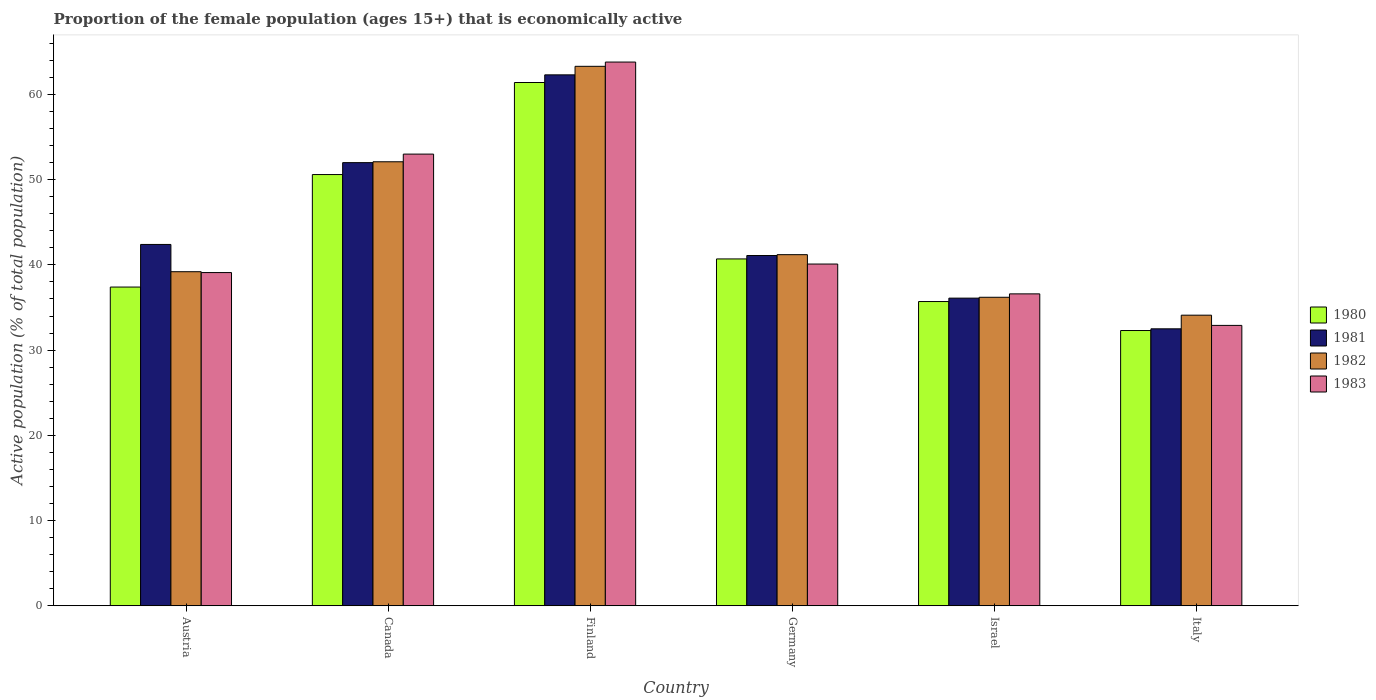How many groups of bars are there?
Your answer should be very brief. 6. Are the number of bars on each tick of the X-axis equal?
Provide a short and direct response. Yes. How many bars are there on the 1st tick from the left?
Give a very brief answer. 4. How many bars are there on the 4th tick from the right?
Keep it short and to the point. 4. What is the proportion of the female population that is economically active in 1980 in Canada?
Provide a short and direct response. 50.6. Across all countries, what is the maximum proportion of the female population that is economically active in 1980?
Make the answer very short. 61.4. Across all countries, what is the minimum proportion of the female population that is economically active in 1980?
Provide a short and direct response. 32.3. What is the total proportion of the female population that is economically active in 1980 in the graph?
Your answer should be compact. 258.1. What is the difference between the proportion of the female population that is economically active in 1981 in Canada and that in Finland?
Provide a short and direct response. -10.3. What is the difference between the proportion of the female population that is economically active in 1983 in Israel and the proportion of the female population that is economically active in 1980 in Canada?
Ensure brevity in your answer.  -14. What is the average proportion of the female population that is economically active in 1981 per country?
Ensure brevity in your answer.  44.4. What is the difference between the proportion of the female population that is economically active of/in 1983 and proportion of the female population that is economically active of/in 1982 in Canada?
Give a very brief answer. 0.9. In how many countries, is the proportion of the female population that is economically active in 1981 greater than 2 %?
Your response must be concise. 6. What is the ratio of the proportion of the female population that is economically active in 1982 in Austria to that in Israel?
Provide a succinct answer. 1.08. Is the difference between the proportion of the female population that is economically active in 1983 in Canada and Germany greater than the difference between the proportion of the female population that is economically active in 1982 in Canada and Germany?
Your answer should be compact. Yes. What is the difference between the highest and the second highest proportion of the female population that is economically active in 1983?
Your answer should be compact. -12.9. What is the difference between the highest and the lowest proportion of the female population that is economically active in 1980?
Offer a very short reply. 29.1. In how many countries, is the proportion of the female population that is economically active in 1983 greater than the average proportion of the female population that is economically active in 1983 taken over all countries?
Give a very brief answer. 2. How many bars are there?
Offer a terse response. 24. Are the values on the major ticks of Y-axis written in scientific E-notation?
Your answer should be compact. No. Does the graph contain grids?
Provide a succinct answer. No. What is the title of the graph?
Your answer should be compact. Proportion of the female population (ages 15+) that is economically active. Does "1976" appear as one of the legend labels in the graph?
Your response must be concise. No. What is the label or title of the X-axis?
Provide a short and direct response. Country. What is the label or title of the Y-axis?
Make the answer very short. Active population (% of total population). What is the Active population (% of total population) of 1980 in Austria?
Your response must be concise. 37.4. What is the Active population (% of total population) in 1981 in Austria?
Your answer should be very brief. 42.4. What is the Active population (% of total population) of 1982 in Austria?
Offer a very short reply. 39.2. What is the Active population (% of total population) in 1983 in Austria?
Your response must be concise. 39.1. What is the Active population (% of total population) of 1980 in Canada?
Offer a very short reply. 50.6. What is the Active population (% of total population) in 1982 in Canada?
Offer a terse response. 52.1. What is the Active population (% of total population) of 1980 in Finland?
Your response must be concise. 61.4. What is the Active population (% of total population) of 1981 in Finland?
Provide a succinct answer. 62.3. What is the Active population (% of total population) in 1982 in Finland?
Provide a short and direct response. 63.3. What is the Active population (% of total population) of 1983 in Finland?
Make the answer very short. 63.8. What is the Active population (% of total population) of 1980 in Germany?
Provide a short and direct response. 40.7. What is the Active population (% of total population) in 1981 in Germany?
Provide a short and direct response. 41.1. What is the Active population (% of total population) of 1982 in Germany?
Provide a succinct answer. 41.2. What is the Active population (% of total population) of 1983 in Germany?
Your answer should be very brief. 40.1. What is the Active population (% of total population) of 1980 in Israel?
Offer a terse response. 35.7. What is the Active population (% of total population) in 1981 in Israel?
Make the answer very short. 36.1. What is the Active population (% of total population) of 1982 in Israel?
Offer a terse response. 36.2. What is the Active population (% of total population) in 1983 in Israel?
Make the answer very short. 36.6. What is the Active population (% of total population) in 1980 in Italy?
Your answer should be very brief. 32.3. What is the Active population (% of total population) in 1981 in Italy?
Your answer should be very brief. 32.5. What is the Active population (% of total population) in 1982 in Italy?
Ensure brevity in your answer.  34.1. What is the Active population (% of total population) of 1983 in Italy?
Your answer should be very brief. 32.9. Across all countries, what is the maximum Active population (% of total population) of 1980?
Your answer should be compact. 61.4. Across all countries, what is the maximum Active population (% of total population) of 1981?
Provide a short and direct response. 62.3. Across all countries, what is the maximum Active population (% of total population) in 1982?
Your answer should be very brief. 63.3. Across all countries, what is the maximum Active population (% of total population) in 1983?
Ensure brevity in your answer.  63.8. Across all countries, what is the minimum Active population (% of total population) in 1980?
Offer a terse response. 32.3. Across all countries, what is the minimum Active population (% of total population) of 1981?
Your answer should be compact. 32.5. Across all countries, what is the minimum Active population (% of total population) of 1982?
Make the answer very short. 34.1. Across all countries, what is the minimum Active population (% of total population) in 1983?
Ensure brevity in your answer.  32.9. What is the total Active population (% of total population) of 1980 in the graph?
Keep it short and to the point. 258.1. What is the total Active population (% of total population) in 1981 in the graph?
Offer a very short reply. 266.4. What is the total Active population (% of total population) of 1982 in the graph?
Offer a terse response. 266.1. What is the total Active population (% of total population) in 1983 in the graph?
Make the answer very short. 265.5. What is the difference between the Active population (% of total population) of 1981 in Austria and that in Canada?
Make the answer very short. -9.6. What is the difference between the Active population (% of total population) of 1982 in Austria and that in Canada?
Your answer should be compact. -12.9. What is the difference between the Active population (% of total population) in 1980 in Austria and that in Finland?
Ensure brevity in your answer.  -24. What is the difference between the Active population (% of total population) of 1981 in Austria and that in Finland?
Offer a very short reply. -19.9. What is the difference between the Active population (% of total population) of 1982 in Austria and that in Finland?
Offer a terse response. -24.1. What is the difference between the Active population (% of total population) of 1983 in Austria and that in Finland?
Offer a terse response. -24.7. What is the difference between the Active population (% of total population) in 1980 in Austria and that in Germany?
Offer a very short reply. -3.3. What is the difference between the Active population (% of total population) in 1981 in Austria and that in Germany?
Make the answer very short. 1.3. What is the difference between the Active population (% of total population) of 1981 in Austria and that in Israel?
Provide a succinct answer. 6.3. What is the difference between the Active population (% of total population) of 1982 in Austria and that in Israel?
Offer a very short reply. 3. What is the difference between the Active population (% of total population) of 1982 in Austria and that in Italy?
Your response must be concise. 5.1. What is the difference between the Active population (% of total population) of 1983 in Austria and that in Italy?
Provide a succinct answer. 6.2. What is the difference between the Active population (% of total population) of 1980 in Canada and that in Finland?
Your response must be concise. -10.8. What is the difference between the Active population (% of total population) in 1982 in Canada and that in Finland?
Provide a short and direct response. -11.2. What is the difference between the Active population (% of total population) in 1983 in Canada and that in Finland?
Your response must be concise. -10.8. What is the difference between the Active population (% of total population) of 1982 in Canada and that in Germany?
Provide a succinct answer. 10.9. What is the difference between the Active population (% of total population) of 1983 in Canada and that in Germany?
Your answer should be compact. 12.9. What is the difference between the Active population (% of total population) in 1980 in Canada and that in Israel?
Make the answer very short. 14.9. What is the difference between the Active population (% of total population) of 1981 in Canada and that in Israel?
Your response must be concise. 15.9. What is the difference between the Active population (% of total population) in 1983 in Canada and that in Italy?
Provide a short and direct response. 20.1. What is the difference between the Active population (% of total population) of 1980 in Finland and that in Germany?
Provide a short and direct response. 20.7. What is the difference between the Active population (% of total population) of 1981 in Finland and that in Germany?
Make the answer very short. 21.2. What is the difference between the Active population (% of total population) in 1982 in Finland and that in Germany?
Provide a short and direct response. 22.1. What is the difference between the Active population (% of total population) in 1983 in Finland and that in Germany?
Your response must be concise. 23.7. What is the difference between the Active population (% of total population) in 1980 in Finland and that in Israel?
Provide a succinct answer. 25.7. What is the difference between the Active population (% of total population) in 1981 in Finland and that in Israel?
Make the answer very short. 26.2. What is the difference between the Active population (% of total population) of 1982 in Finland and that in Israel?
Your response must be concise. 27.1. What is the difference between the Active population (% of total population) of 1983 in Finland and that in Israel?
Provide a short and direct response. 27.2. What is the difference between the Active population (% of total population) of 1980 in Finland and that in Italy?
Offer a terse response. 29.1. What is the difference between the Active population (% of total population) in 1981 in Finland and that in Italy?
Your answer should be very brief. 29.8. What is the difference between the Active population (% of total population) in 1982 in Finland and that in Italy?
Offer a terse response. 29.2. What is the difference between the Active population (% of total population) in 1983 in Finland and that in Italy?
Provide a short and direct response. 30.9. What is the difference between the Active population (% of total population) in 1980 in Germany and that in Italy?
Your response must be concise. 8.4. What is the difference between the Active population (% of total population) of 1982 in Germany and that in Italy?
Ensure brevity in your answer.  7.1. What is the difference between the Active population (% of total population) in 1981 in Israel and that in Italy?
Offer a terse response. 3.6. What is the difference between the Active population (% of total population) in 1983 in Israel and that in Italy?
Provide a short and direct response. 3.7. What is the difference between the Active population (% of total population) in 1980 in Austria and the Active population (% of total population) in 1981 in Canada?
Your response must be concise. -14.6. What is the difference between the Active population (% of total population) in 1980 in Austria and the Active population (% of total population) in 1982 in Canada?
Give a very brief answer. -14.7. What is the difference between the Active population (% of total population) of 1980 in Austria and the Active population (% of total population) of 1983 in Canada?
Your answer should be compact. -15.6. What is the difference between the Active population (% of total population) of 1981 in Austria and the Active population (% of total population) of 1983 in Canada?
Make the answer very short. -10.6. What is the difference between the Active population (% of total population) in 1982 in Austria and the Active population (% of total population) in 1983 in Canada?
Give a very brief answer. -13.8. What is the difference between the Active population (% of total population) of 1980 in Austria and the Active population (% of total population) of 1981 in Finland?
Offer a terse response. -24.9. What is the difference between the Active population (% of total population) of 1980 in Austria and the Active population (% of total population) of 1982 in Finland?
Your response must be concise. -25.9. What is the difference between the Active population (% of total population) in 1980 in Austria and the Active population (% of total population) in 1983 in Finland?
Your response must be concise. -26.4. What is the difference between the Active population (% of total population) in 1981 in Austria and the Active population (% of total population) in 1982 in Finland?
Make the answer very short. -20.9. What is the difference between the Active population (% of total population) in 1981 in Austria and the Active population (% of total population) in 1983 in Finland?
Your answer should be very brief. -21.4. What is the difference between the Active population (% of total population) of 1982 in Austria and the Active population (% of total population) of 1983 in Finland?
Offer a terse response. -24.6. What is the difference between the Active population (% of total population) in 1981 in Austria and the Active population (% of total population) in 1983 in Germany?
Offer a very short reply. 2.3. What is the difference between the Active population (% of total population) in 1982 in Austria and the Active population (% of total population) in 1983 in Germany?
Provide a short and direct response. -0.9. What is the difference between the Active population (% of total population) in 1980 in Austria and the Active population (% of total population) in 1983 in Israel?
Offer a terse response. 0.8. What is the difference between the Active population (% of total population) of 1981 in Austria and the Active population (% of total population) of 1982 in Israel?
Your response must be concise. 6.2. What is the difference between the Active population (% of total population) of 1981 in Austria and the Active population (% of total population) of 1983 in Israel?
Provide a short and direct response. 5.8. What is the difference between the Active population (% of total population) in 1982 in Austria and the Active population (% of total population) in 1983 in Israel?
Make the answer very short. 2.6. What is the difference between the Active population (% of total population) of 1980 in Austria and the Active population (% of total population) of 1982 in Italy?
Offer a very short reply. 3.3. What is the difference between the Active population (% of total population) of 1981 in Austria and the Active population (% of total population) of 1983 in Italy?
Provide a short and direct response. 9.5. What is the difference between the Active population (% of total population) of 1982 in Austria and the Active population (% of total population) of 1983 in Italy?
Offer a terse response. 6.3. What is the difference between the Active population (% of total population) in 1980 in Canada and the Active population (% of total population) in 1981 in Finland?
Offer a very short reply. -11.7. What is the difference between the Active population (% of total population) in 1980 in Canada and the Active population (% of total population) in 1982 in Finland?
Provide a short and direct response. -12.7. What is the difference between the Active population (% of total population) of 1981 in Canada and the Active population (% of total population) of 1982 in Finland?
Offer a very short reply. -11.3. What is the difference between the Active population (% of total population) in 1982 in Canada and the Active population (% of total population) in 1983 in Finland?
Give a very brief answer. -11.7. What is the difference between the Active population (% of total population) of 1980 in Canada and the Active population (% of total population) of 1982 in Germany?
Your response must be concise. 9.4. What is the difference between the Active population (% of total population) in 1981 in Canada and the Active population (% of total population) in 1982 in Germany?
Keep it short and to the point. 10.8. What is the difference between the Active population (% of total population) in 1981 in Canada and the Active population (% of total population) in 1983 in Germany?
Make the answer very short. 11.9. What is the difference between the Active population (% of total population) of 1982 in Canada and the Active population (% of total population) of 1983 in Germany?
Give a very brief answer. 12. What is the difference between the Active population (% of total population) in 1980 in Canada and the Active population (% of total population) in 1982 in Israel?
Offer a terse response. 14.4. What is the difference between the Active population (% of total population) in 1980 in Canada and the Active population (% of total population) in 1981 in Italy?
Offer a very short reply. 18.1. What is the difference between the Active population (% of total population) of 1980 in Canada and the Active population (% of total population) of 1982 in Italy?
Offer a very short reply. 16.5. What is the difference between the Active population (% of total population) in 1980 in Canada and the Active population (% of total population) in 1983 in Italy?
Ensure brevity in your answer.  17.7. What is the difference between the Active population (% of total population) in 1980 in Finland and the Active population (% of total population) in 1981 in Germany?
Offer a very short reply. 20.3. What is the difference between the Active population (% of total population) in 1980 in Finland and the Active population (% of total population) in 1982 in Germany?
Your response must be concise. 20.2. What is the difference between the Active population (% of total population) of 1980 in Finland and the Active population (% of total population) of 1983 in Germany?
Offer a very short reply. 21.3. What is the difference between the Active population (% of total population) of 1981 in Finland and the Active population (% of total population) of 1982 in Germany?
Ensure brevity in your answer.  21.1. What is the difference between the Active population (% of total population) of 1982 in Finland and the Active population (% of total population) of 1983 in Germany?
Keep it short and to the point. 23.2. What is the difference between the Active population (% of total population) of 1980 in Finland and the Active population (% of total population) of 1981 in Israel?
Offer a very short reply. 25.3. What is the difference between the Active population (% of total population) in 1980 in Finland and the Active population (% of total population) in 1982 in Israel?
Make the answer very short. 25.2. What is the difference between the Active population (% of total population) of 1980 in Finland and the Active population (% of total population) of 1983 in Israel?
Provide a succinct answer. 24.8. What is the difference between the Active population (% of total population) of 1981 in Finland and the Active population (% of total population) of 1982 in Israel?
Keep it short and to the point. 26.1. What is the difference between the Active population (% of total population) of 1981 in Finland and the Active population (% of total population) of 1983 in Israel?
Your answer should be compact. 25.7. What is the difference between the Active population (% of total population) in 1982 in Finland and the Active population (% of total population) in 1983 in Israel?
Offer a terse response. 26.7. What is the difference between the Active population (% of total population) in 1980 in Finland and the Active population (% of total population) in 1981 in Italy?
Provide a succinct answer. 28.9. What is the difference between the Active population (% of total population) of 1980 in Finland and the Active population (% of total population) of 1982 in Italy?
Your response must be concise. 27.3. What is the difference between the Active population (% of total population) in 1980 in Finland and the Active population (% of total population) in 1983 in Italy?
Keep it short and to the point. 28.5. What is the difference between the Active population (% of total population) in 1981 in Finland and the Active population (% of total population) in 1982 in Italy?
Ensure brevity in your answer.  28.2. What is the difference between the Active population (% of total population) of 1981 in Finland and the Active population (% of total population) of 1983 in Italy?
Offer a very short reply. 29.4. What is the difference between the Active population (% of total population) of 1982 in Finland and the Active population (% of total population) of 1983 in Italy?
Offer a terse response. 30.4. What is the difference between the Active population (% of total population) in 1980 in Germany and the Active population (% of total population) in 1981 in Israel?
Your response must be concise. 4.6. What is the difference between the Active population (% of total population) in 1981 in Germany and the Active population (% of total population) in 1982 in Israel?
Offer a very short reply. 4.9. What is the difference between the Active population (% of total population) of 1980 in Germany and the Active population (% of total population) of 1981 in Italy?
Keep it short and to the point. 8.2. What is the difference between the Active population (% of total population) of 1980 in Germany and the Active population (% of total population) of 1982 in Italy?
Offer a very short reply. 6.6. What is the difference between the Active population (% of total population) of 1981 in Germany and the Active population (% of total population) of 1982 in Italy?
Offer a terse response. 7. What is the difference between the Active population (% of total population) in 1981 in Germany and the Active population (% of total population) in 1983 in Italy?
Your answer should be very brief. 8.2. What is the difference between the Active population (% of total population) of 1980 in Israel and the Active population (% of total population) of 1982 in Italy?
Your answer should be compact. 1.6. What is the difference between the Active population (% of total population) of 1981 in Israel and the Active population (% of total population) of 1983 in Italy?
Offer a terse response. 3.2. What is the difference between the Active population (% of total population) of 1982 in Israel and the Active population (% of total population) of 1983 in Italy?
Keep it short and to the point. 3.3. What is the average Active population (% of total population) of 1980 per country?
Keep it short and to the point. 43.02. What is the average Active population (% of total population) of 1981 per country?
Your answer should be compact. 44.4. What is the average Active population (% of total population) in 1982 per country?
Provide a short and direct response. 44.35. What is the average Active population (% of total population) in 1983 per country?
Ensure brevity in your answer.  44.25. What is the difference between the Active population (% of total population) of 1981 and Active population (% of total population) of 1982 in Austria?
Ensure brevity in your answer.  3.2. What is the difference between the Active population (% of total population) of 1981 and Active population (% of total population) of 1983 in Austria?
Ensure brevity in your answer.  3.3. What is the difference between the Active population (% of total population) of 1982 and Active population (% of total population) of 1983 in Austria?
Make the answer very short. 0.1. What is the difference between the Active population (% of total population) of 1981 and Active population (% of total population) of 1983 in Canada?
Give a very brief answer. -1. What is the difference between the Active population (% of total population) in 1980 and Active population (% of total population) in 1983 in Finland?
Provide a short and direct response. -2.4. What is the difference between the Active population (% of total population) in 1981 and Active population (% of total population) in 1982 in Finland?
Offer a very short reply. -1. What is the difference between the Active population (% of total population) of 1982 and Active population (% of total population) of 1983 in Finland?
Offer a terse response. -0.5. What is the difference between the Active population (% of total population) of 1980 and Active population (% of total population) of 1981 in Germany?
Offer a terse response. -0.4. What is the difference between the Active population (% of total population) of 1980 and Active population (% of total population) of 1983 in Germany?
Your response must be concise. 0.6. What is the difference between the Active population (% of total population) of 1981 and Active population (% of total population) of 1982 in Germany?
Offer a very short reply. -0.1. What is the difference between the Active population (% of total population) in 1981 and Active population (% of total population) in 1983 in Germany?
Give a very brief answer. 1. What is the difference between the Active population (% of total population) in 1980 and Active population (% of total population) in 1981 in Israel?
Make the answer very short. -0.4. What is the difference between the Active population (% of total population) in 1981 and Active population (% of total population) in 1982 in Israel?
Your answer should be very brief. -0.1. What is the difference between the Active population (% of total population) of 1981 and Active population (% of total population) of 1983 in Israel?
Provide a succinct answer. -0.5. What is the difference between the Active population (% of total population) in 1982 and Active population (% of total population) in 1983 in Israel?
Your answer should be compact. -0.4. What is the difference between the Active population (% of total population) in 1980 and Active population (% of total population) in 1983 in Italy?
Make the answer very short. -0.6. What is the difference between the Active population (% of total population) of 1981 and Active population (% of total population) of 1982 in Italy?
Offer a terse response. -1.6. What is the difference between the Active population (% of total population) in 1981 and Active population (% of total population) in 1983 in Italy?
Your response must be concise. -0.4. What is the difference between the Active population (% of total population) of 1982 and Active population (% of total population) of 1983 in Italy?
Offer a terse response. 1.2. What is the ratio of the Active population (% of total population) in 1980 in Austria to that in Canada?
Offer a terse response. 0.74. What is the ratio of the Active population (% of total population) of 1981 in Austria to that in Canada?
Provide a succinct answer. 0.82. What is the ratio of the Active population (% of total population) of 1982 in Austria to that in Canada?
Make the answer very short. 0.75. What is the ratio of the Active population (% of total population) of 1983 in Austria to that in Canada?
Offer a very short reply. 0.74. What is the ratio of the Active population (% of total population) of 1980 in Austria to that in Finland?
Provide a succinct answer. 0.61. What is the ratio of the Active population (% of total population) of 1981 in Austria to that in Finland?
Provide a short and direct response. 0.68. What is the ratio of the Active population (% of total population) in 1982 in Austria to that in Finland?
Your answer should be very brief. 0.62. What is the ratio of the Active population (% of total population) in 1983 in Austria to that in Finland?
Offer a terse response. 0.61. What is the ratio of the Active population (% of total population) of 1980 in Austria to that in Germany?
Ensure brevity in your answer.  0.92. What is the ratio of the Active population (% of total population) of 1981 in Austria to that in Germany?
Give a very brief answer. 1.03. What is the ratio of the Active population (% of total population) in 1982 in Austria to that in Germany?
Provide a short and direct response. 0.95. What is the ratio of the Active population (% of total population) in 1983 in Austria to that in Germany?
Provide a succinct answer. 0.98. What is the ratio of the Active population (% of total population) in 1980 in Austria to that in Israel?
Ensure brevity in your answer.  1.05. What is the ratio of the Active population (% of total population) in 1981 in Austria to that in Israel?
Provide a succinct answer. 1.17. What is the ratio of the Active population (% of total population) of 1982 in Austria to that in Israel?
Make the answer very short. 1.08. What is the ratio of the Active population (% of total population) in 1983 in Austria to that in Israel?
Your answer should be very brief. 1.07. What is the ratio of the Active population (% of total population) of 1980 in Austria to that in Italy?
Provide a short and direct response. 1.16. What is the ratio of the Active population (% of total population) of 1981 in Austria to that in Italy?
Make the answer very short. 1.3. What is the ratio of the Active population (% of total population) in 1982 in Austria to that in Italy?
Provide a succinct answer. 1.15. What is the ratio of the Active population (% of total population) of 1983 in Austria to that in Italy?
Provide a short and direct response. 1.19. What is the ratio of the Active population (% of total population) of 1980 in Canada to that in Finland?
Make the answer very short. 0.82. What is the ratio of the Active population (% of total population) in 1981 in Canada to that in Finland?
Your answer should be very brief. 0.83. What is the ratio of the Active population (% of total population) of 1982 in Canada to that in Finland?
Offer a terse response. 0.82. What is the ratio of the Active population (% of total population) of 1983 in Canada to that in Finland?
Your answer should be very brief. 0.83. What is the ratio of the Active population (% of total population) of 1980 in Canada to that in Germany?
Keep it short and to the point. 1.24. What is the ratio of the Active population (% of total population) in 1981 in Canada to that in Germany?
Keep it short and to the point. 1.27. What is the ratio of the Active population (% of total population) in 1982 in Canada to that in Germany?
Your answer should be compact. 1.26. What is the ratio of the Active population (% of total population) of 1983 in Canada to that in Germany?
Keep it short and to the point. 1.32. What is the ratio of the Active population (% of total population) in 1980 in Canada to that in Israel?
Provide a succinct answer. 1.42. What is the ratio of the Active population (% of total population) in 1981 in Canada to that in Israel?
Provide a succinct answer. 1.44. What is the ratio of the Active population (% of total population) in 1982 in Canada to that in Israel?
Offer a terse response. 1.44. What is the ratio of the Active population (% of total population) of 1983 in Canada to that in Israel?
Ensure brevity in your answer.  1.45. What is the ratio of the Active population (% of total population) in 1980 in Canada to that in Italy?
Offer a very short reply. 1.57. What is the ratio of the Active population (% of total population) in 1982 in Canada to that in Italy?
Offer a very short reply. 1.53. What is the ratio of the Active population (% of total population) of 1983 in Canada to that in Italy?
Make the answer very short. 1.61. What is the ratio of the Active population (% of total population) of 1980 in Finland to that in Germany?
Your response must be concise. 1.51. What is the ratio of the Active population (% of total population) of 1981 in Finland to that in Germany?
Offer a terse response. 1.52. What is the ratio of the Active population (% of total population) of 1982 in Finland to that in Germany?
Your response must be concise. 1.54. What is the ratio of the Active population (% of total population) of 1983 in Finland to that in Germany?
Your answer should be very brief. 1.59. What is the ratio of the Active population (% of total population) in 1980 in Finland to that in Israel?
Offer a very short reply. 1.72. What is the ratio of the Active population (% of total population) of 1981 in Finland to that in Israel?
Ensure brevity in your answer.  1.73. What is the ratio of the Active population (% of total population) of 1982 in Finland to that in Israel?
Offer a terse response. 1.75. What is the ratio of the Active population (% of total population) in 1983 in Finland to that in Israel?
Keep it short and to the point. 1.74. What is the ratio of the Active population (% of total population) in 1980 in Finland to that in Italy?
Provide a succinct answer. 1.9. What is the ratio of the Active population (% of total population) of 1981 in Finland to that in Italy?
Your answer should be very brief. 1.92. What is the ratio of the Active population (% of total population) of 1982 in Finland to that in Italy?
Offer a terse response. 1.86. What is the ratio of the Active population (% of total population) in 1983 in Finland to that in Italy?
Make the answer very short. 1.94. What is the ratio of the Active population (% of total population) of 1980 in Germany to that in Israel?
Provide a short and direct response. 1.14. What is the ratio of the Active population (% of total population) in 1981 in Germany to that in Israel?
Give a very brief answer. 1.14. What is the ratio of the Active population (% of total population) of 1982 in Germany to that in Israel?
Offer a terse response. 1.14. What is the ratio of the Active population (% of total population) in 1983 in Germany to that in Israel?
Offer a terse response. 1.1. What is the ratio of the Active population (% of total population) of 1980 in Germany to that in Italy?
Give a very brief answer. 1.26. What is the ratio of the Active population (% of total population) in 1981 in Germany to that in Italy?
Offer a terse response. 1.26. What is the ratio of the Active population (% of total population) of 1982 in Germany to that in Italy?
Provide a short and direct response. 1.21. What is the ratio of the Active population (% of total population) of 1983 in Germany to that in Italy?
Your response must be concise. 1.22. What is the ratio of the Active population (% of total population) of 1980 in Israel to that in Italy?
Provide a short and direct response. 1.11. What is the ratio of the Active population (% of total population) in 1981 in Israel to that in Italy?
Give a very brief answer. 1.11. What is the ratio of the Active population (% of total population) in 1982 in Israel to that in Italy?
Offer a very short reply. 1.06. What is the ratio of the Active population (% of total population) in 1983 in Israel to that in Italy?
Keep it short and to the point. 1.11. What is the difference between the highest and the second highest Active population (% of total population) in 1980?
Provide a short and direct response. 10.8. What is the difference between the highest and the second highest Active population (% of total population) in 1982?
Provide a short and direct response. 11.2. What is the difference between the highest and the second highest Active population (% of total population) in 1983?
Make the answer very short. 10.8. What is the difference between the highest and the lowest Active population (% of total population) in 1980?
Offer a very short reply. 29.1. What is the difference between the highest and the lowest Active population (% of total population) of 1981?
Keep it short and to the point. 29.8. What is the difference between the highest and the lowest Active population (% of total population) of 1982?
Keep it short and to the point. 29.2. What is the difference between the highest and the lowest Active population (% of total population) in 1983?
Your response must be concise. 30.9. 